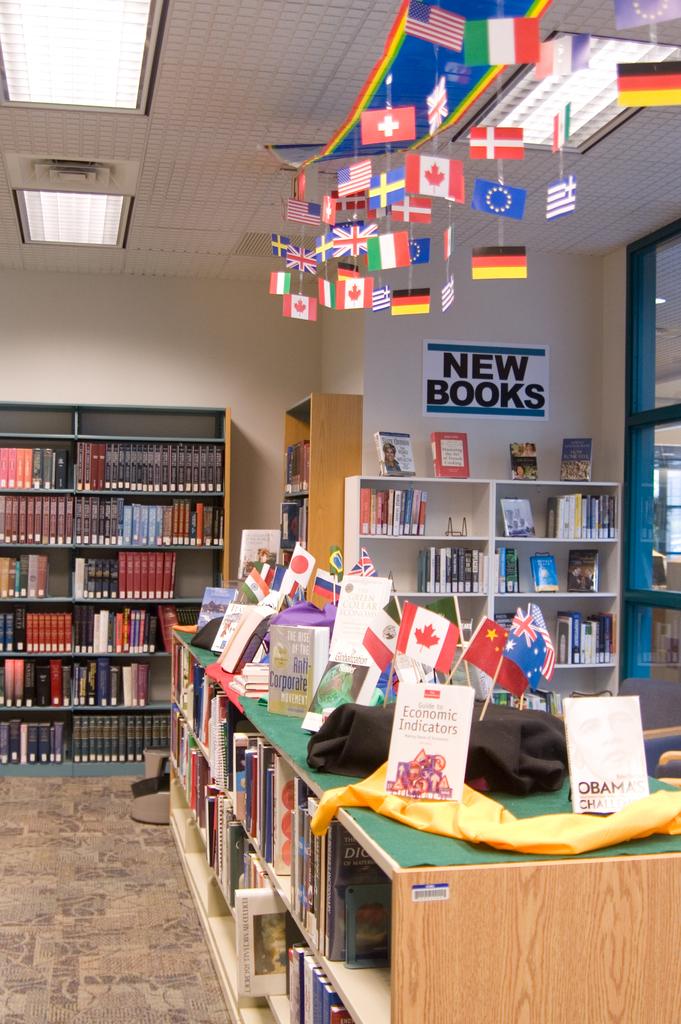What kind of books are advertised?
Your answer should be compact. New. What is the name of the book facing the camera?
Provide a short and direct response. Economic indicators. 